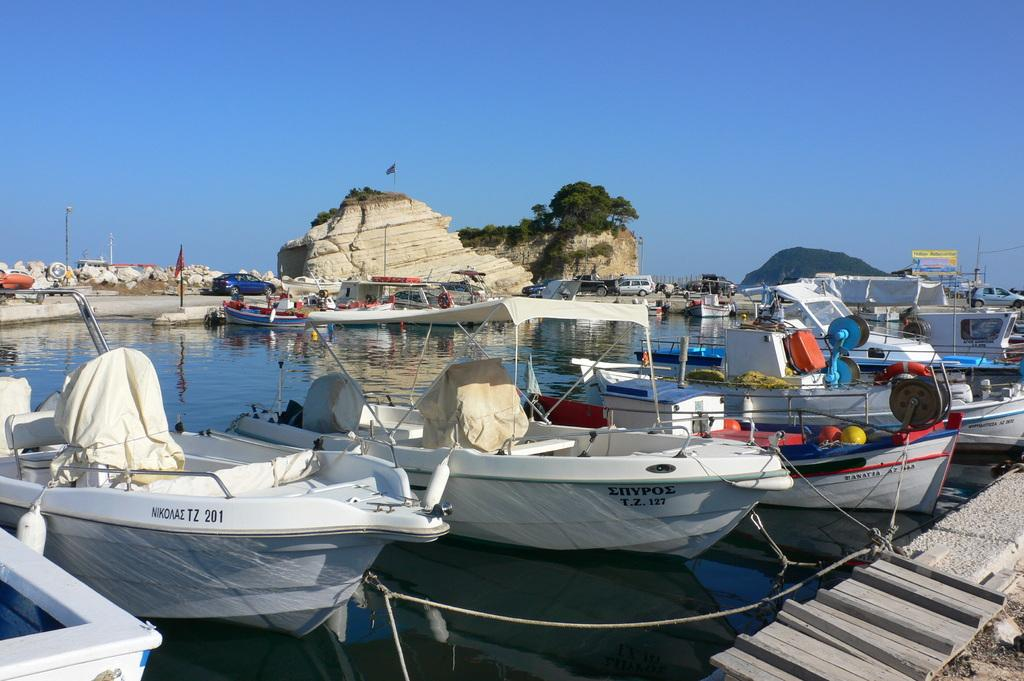What is in the water in the image? There are boats in the water in the image. How are the boats secured in the water? The boats are tied with ropes. What can be seen behind the boats? There are poles behind the boats. What is visible in the distance in the image? Hills and trees are present in the background. What type of transportation can be seen in the background? Vehicles are on a path in the background. What part of the natural environment is visible in the image? The sky is visible in the image. What type of beef is being served on the boats in the image? There is no beef present in the image; it features boats in the water. What is the quiver used for in the image? There is no quiver present in the image. 